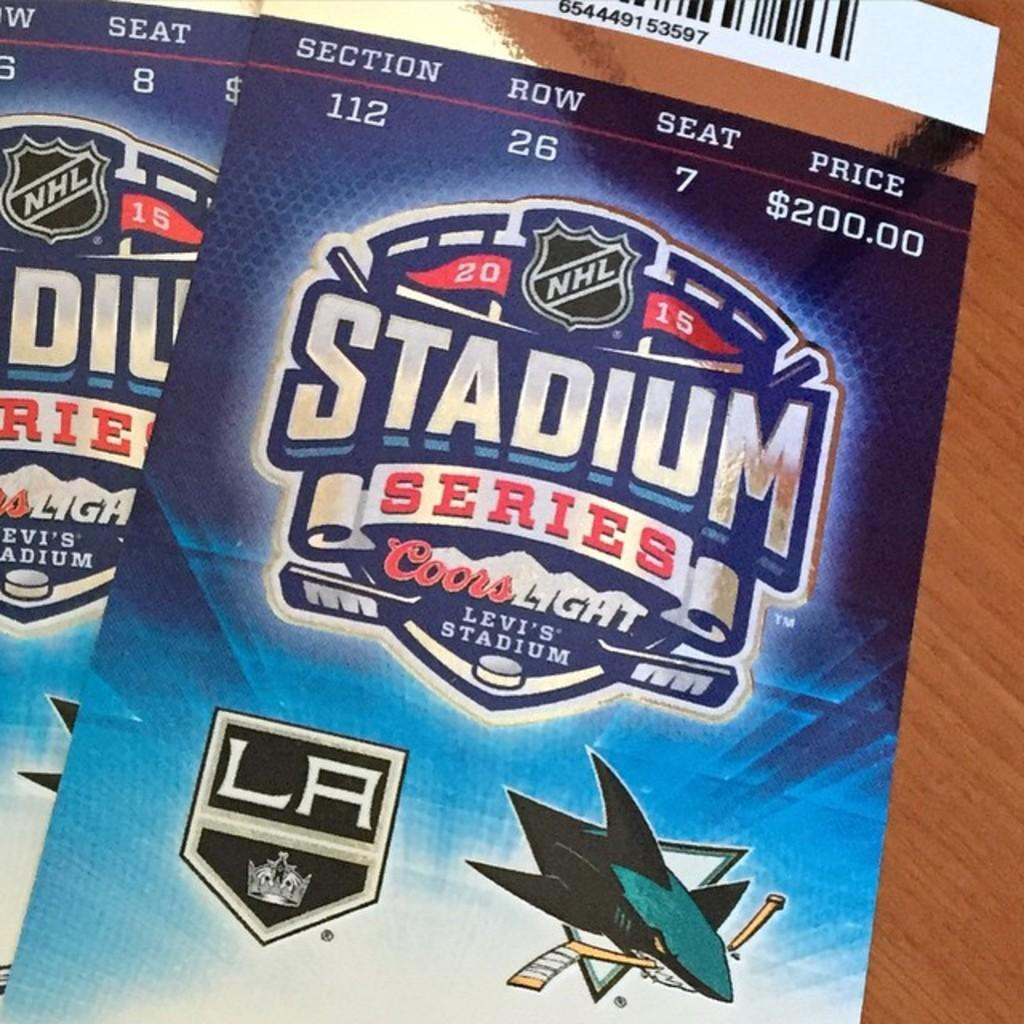What type of item can be seen in the image? There are tickets in the image. What information is provided on the tickets? The tickets have seat numbers and prices. What is the purpose of the brick in the image? There is no brick present in the image. 